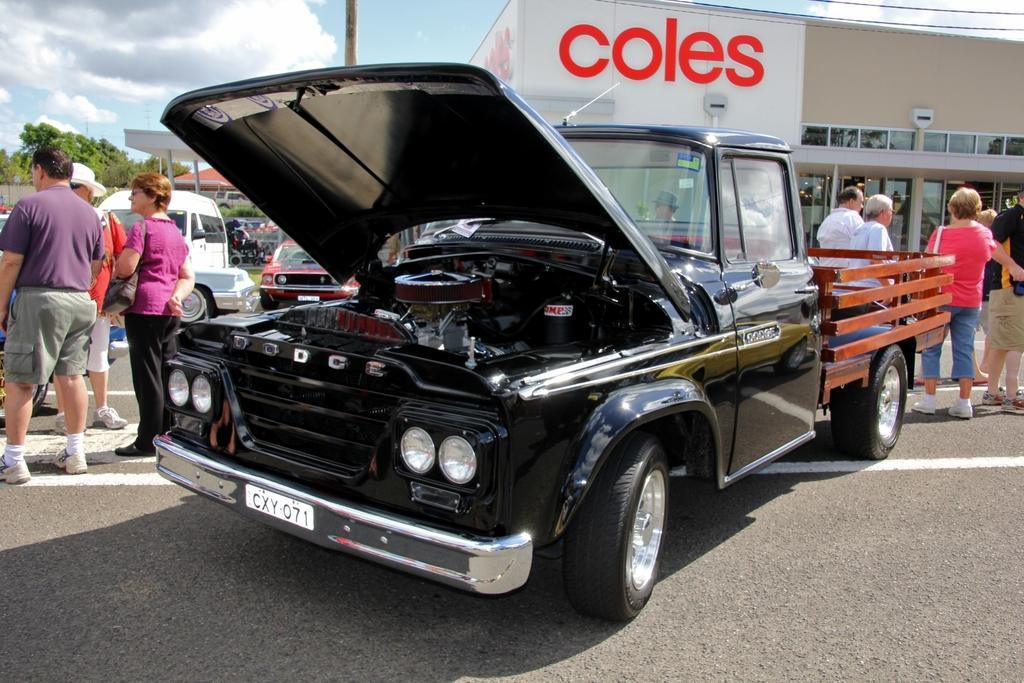Please provide a concise description of this image. In front of the image there is a car, around the car there are a few people standing and there are other cars parked, in the background of the image there is a lamp post, buildings and trees, at the top of the image there are clouds in the sky. 